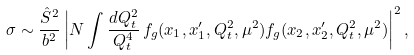Convert formula to latex. <formula><loc_0><loc_0><loc_500><loc_500>\sigma \sim \frac { { \hat { S } } ^ { 2 } } { b ^ { 2 } } \left | N \int \frac { d Q ^ { 2 } _ { t } } { Q ^ { 4 } _ { t } } \, f _ { g } ( x _ { 1 } , x _ { 1 } ^ { \prime } , Q _ { t } ^ { 2 } , \mu ^ { 2 } ) f _ { g } ( x _ { 2 } , x _ { 2 } ^ { \prime } , Q _ { t } ^ { 2 } , \mu ^ { 2 } ) \right | ^ { 2 } ,</formula> 